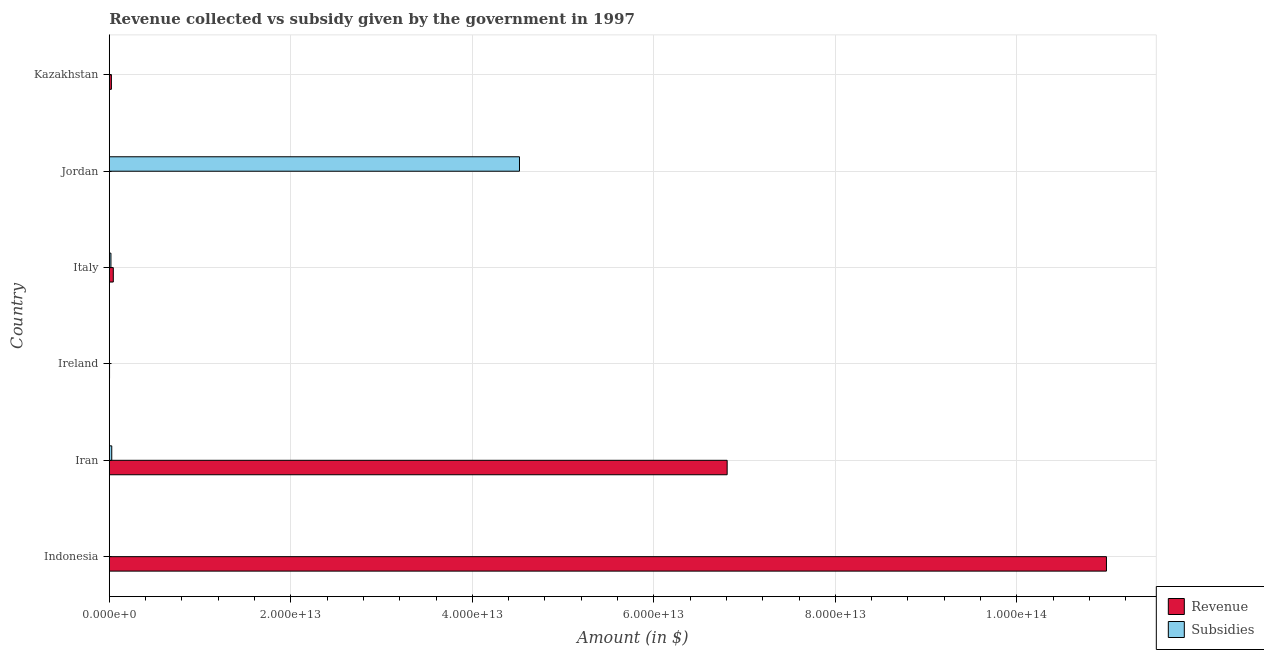Are the number of bars per tick equal to the number of legend labels?
Keep it short and to the point. Yes. Are the number of bars on each tick of the Y-axis equal?
Offer a terse response. Yes. How many bars are there on the 4th tick from the top?
Offer a very short reply. 2. How many bars are there on the 1st tick from the bottom?
Make the answer very short. 2. What is the label of the 3rd group of bars from the top?
Keep it short and to the point. Italy. What is the amount of subsidies given in Italy?
Offer a terse response. 1.83e+11. Across all countries, what is the maximum amount of subsidies given?
Ensure brevity in your answer.  4.52e+13. Across all countries, what is the minimum amount of subsidies given?
Offer a terse response. 1.45e+08. In which country was the amount of revenue collected maximum?
Give a very brief answer. Indonesia. In which country was the amount of revenue collected minimum?
Give a very brief answer. Jordan. What is the total amount of revenue collected in the graph?
Give a very brief answer. 1.79e+14. What is the difference between the amount of revenue collected in Ireland and that in Kazakhstan?
Your response must be concise. -2.04e+11. What is the difference between the amount of revenue collected in Iran and the amount of subsidies given in Jordan?
Your answer should be very brief. 2.29e+13. What is the average amount of subsidies given per country?
Provide a short and direct response. 7.61e+12. What is the difference between the amount of subsidies given and amount of revenue collected in Jordan?
Keep it short and to the point. 4.52e+13. In how many countries, is the amount of revenue collected greater than 64000000000000 $?
Ensure brevity in your answer.  2. What is the ratio of the amount of revenue collected in Indonesia to that in Ireland?
Your answer should be very brief. 3674.79. Is the difference between the amount of revenue collected in Iran and Kazakhstan greater than the difference between the amount of subsidies given in Iran and Kazakhstan?
Give a very brief answer. Yes. What is the difference between the highest and the second highest amount of subsidies given?
Your answer should be compact. 4.49e+13. What is the difference between the highest and the lowest amount of revenue collected?
Provide a succinct answer. 1.10e+14. In how many countries, is the amount of subsidies given greater than the average amount of subsidies given taken over all countries?
Ensure brevity in your answer.  1. What does the 2nd bar from the top in Italy represents?
Offer a very short reply. Revenue. What does the 2nd bar from the bottom in Iran represents?
Provide a short and direct response. Subsidies. How many bars are there?
Provide a succinct answer. 12. How many countries are there in the graph?
Your response must be concise. 6. What is the difference between two consecutive major ticks on the X-axis?
Make the answer very short. 2.00e+13. Are the values on the major ticks of X-axis written in scientific E-notation?
Ensure brevity in your answer.  Yes. Does the graph contain any zero values?
Provide a succinct answer. No. Does the graph contain grids?
Ensure brevity in your answer.  Yes. How are the legend labels stacked?
Offer a terse response. Vertical. What is the title of the graph?
Make the answer very short. Revenue collected vs subsidy given by the government in 1997. What is the label or title of the X-axis?
Provide a short and direct response. Amount (in $). What is the Amount (in $) of Revenue in Indonesia?
Your answer should be very brief. 1.10e+14. What is the Amount (in $) in Subsidies in Indonesia?
Offer a terse response. 9.20e+09. What is the Amount (in $) of Revenue in Iran?
Offer a very short reply. 6.81e+13. What is the Amount (in $) in Subsidies in Iran?
Make the answer very short. 2.72e+11. What is the Amount (in $) of Revenue in Ireland?
Provide a short and direct response. 2.99e+1. What is the Amount (in $) in Subsidies in Ireland?
Give a very brief answer. 1.45e+08. What is the Amount (in $) in Revenue in Italy?
Keep it short and to the point. 4.44e+11. What is the Amount (in $) in Subsidies in Italy?
Your answer should be very brief. 1.83e+11. What is the Amount (in $) in Revenue in Jordan?
Keep it short and to the point. 1.31e+09. What is the Amount (in $) of Subsidies in Jordan?
Make the answer very short. 4.52e+13. What is the Amount (in $) in Revenue in Kazakhstan?
Your response must be concise. 2.34e+11. What is the Amount (in $) of Subsidies in Kazakhstan?
Provide a succinct answer. 7.52e+08. Across all countries, what is the maximum Amount (in $) of Revenue?
Give a very brief answer. 1.10e+14. Across all countries, what is the maximum Amount (in $) of Subsidies?
Provide a succinct answer. 4.52e+13. Across all countries, what is the minimum Amount (in $) in Revenue?
Give a very brief answer. 1.31e+09. Across all countries, what is the minimum Amount (in $) in Subsidies?
Keep it short and to the point. 1.45e+08. What is the total Amount (in $) of Revenue in the graph?
Your response must be concise. 1.79e+14. What is the total Amount (in $) of Subsidies in the graph?
Provide a short and direct response. 4.57e+13. What is the difference between the Amount (in $) in Revenue in Indonesia and that in Iran?
Offer a very short reply. 4.18e+13. What is the difference between the Amount (in $) of Subsidies in Indonesia and that in Iran?
Provide a succinct answer. -2.63e+11. What is the difference between the Amount (in $) in Revenue in Indonesia and that in Ireland?
Provide a short and direct response. 1.10e+14. What is the difference between the Amount (in $) of Subsidies in Indonesia and that in Ireland?
Offer a very short reply. 9.05e+09. What is the difference between the Amount (in $) in Revenue in Indonesia and that in Italy?
Ensure brevity in your answer.  1.09e+14. What is the difference between the Amount (in $) in Subsidies in Indonesia and that in Italy?
Ensure brevity in your answer.  -1.74e+11. What is the difference between the Amount (in $) of Revenue in Indonesia and that in Jordan?
Offer a terse response. 1.10e+14. What is the difference between the Amount (in $) in Subsidies in Indonesia and that in Jordan?
Your response must be concise. -4.52e+13. What is the difference between the Amount (in $) in Revenue in Indonesia and that in Kazakhstan?
Your answer should be very brief. 1.10e+14. What is the difference between the Amount (in $) of Subsidies in Indonesia and that in Kazakhstan?
Provide a short and direct response. 8.44e+09. What is the difference between the Amount (in $) in Revenue in Iran and that in Ireland?
Ensure brevity in your answer.  6.81e+13. What is the difference between the Amount (in $) of Subsidies in Iran and that in Ireland?
Offer a terse response. 2.72e+11. What is the difference between the Amount (in $) of Revenue in Iran and that in Italy?
Make the answer very short. 6.76e+13. What is the difference between the Amount (in $) of Subsidies in Iran and that in Italy?
Provide a succinct answer. 8.93e+1. What is the difference between the Amount (in $) of Revenue in Iran and that in Jordan?
Give a very brief answer. 6.81e+13. What is the difference between the Amount (in $) in Subsidies in Iran and that in Jordan?
Provide a short and direct response. -4.49e+13. What is the difference between the Amount (in $) of Revenue in Iran and that in Kazakhstan?
Give a very brief answer. 6.78e+13. What is the difference between the Amount (in $) of Subsidies in Iran and that in Kazakhstan?
Provide a short and direct response. 2.71e+11. What is the difference between the Amount (in $) in Revenue in Ireland and that in Italy?
Make the answer very short. -4.14e+11. What is the difference between the Amount (in $) in Subsidies in Ireland and that in Italy?
Keep it short and to the point. -1.83e+11. What is the difference between the Amount (in $) in Revenue in Ireland and that in Jordan?
Ensure brevity in your answer.  2.86e+1. What is the difference between the Amount (in $) of Subsidies in Ireland and that in Jordan?
Offer a terse response. -4.52e+13. What is the difference between the Amount (in $) of Revenue in Ireland and that in Kazakhstan?
Your answer should be compact. -2.04e+11. What is the difference between the Amount (in $) in Subsidies in Ireland and that in Kazakhstan?
Provide a short and direct response. -6.07e+08. What is the difference between the Amount (in $) of Revenue in Italy and that in Jordan?
Your answer should be compact. 4.42e+11. What is the difference between the Amount (in $) in Subsidies in Italy and that in Jordan?
Offer a very short reply. -4.50e+13. What is the difference between the Amount (in $) in Revenue in Italy and that in Kazakhstan?
Provide a short and direct response. 2.10e+11. What is the difference between the Amount (in $) of Subsidies in Italy and that in Kazakhstan?
Offer a terse response. 1.82e+11. What is the difference between the Amount (in $) of Revenue in Jordan and that in Kazakhstan?
Ensure brevity in your answer.  -2.32e+11. What is the difference between the Amount (in $) in Subsidies in Jordan and that in Kazakhstan?
Offer a very short reply. 4.52e+13. What is the difference between the Amount (in $) in Revenue in Indonesia and the Amount (in $) in Subsidies in Iran?
Ensure brevity in your answer.  1.10e+14. What is the difference between the Amount (in $) in Revenue in Indonesia and the Amount (in $) in Subsidies in Ireland?
Keep it short and to the point. 1.10e+14. What is the difference between the Amount (in $) of Revenue in Indonesia and the Amount (in $) of Subsidies in Italy?
Provide a short and direct response. 1.10e+14. What is the difference between the Amount (in $) of Revenue in Indonesia and the Amount (in $) of Subsidies in Jordan?
Offer a very short reply. 6.47e+13. What is the difference between the Amount (in $) in Revenue in Indonesia and the Amount (in $) in Subsidies in Kazakhstan?
Provide a short and direct response. 1.10e+14. What is the difference between the Amount (in $) of Revenue in Iran and the Amount (in $) of Subsidies in Ireland?
Keep it short and to the point. 6.81e+13. What is the difference between the Amount (in $) in Revenue in Iran and the Amount (in $) in Subsidies in Italy?
Your answer should be compact. 6.79e+13. What is the difference between the Amount (in $) in Revenue in Iran and the Amount (in $) in Subsidies in Jordan?
Keep it short and to the point. 2.29e+13. What is the difference between the Amount (in $) of Revenue in Iran and the Amount (in $) of Subsidies in Kazakhstan?
Offer a very short reply. 6.81e+13. What is the difference between the Amount (in $) of Revenue in Ireland and the Amount (in $) of Subsidies in Italy?
Provide a succinct answer. -1.53e+11. What is the difference between the Amount (in $) in Revenue in Ireland and the Amount (in $) in Subsidies in Jordan?
Offer a very short reply. -4.52e+13. What is the difference between the Amount (in $) in Revenue in Ireland and the Amount (in $) in Subsidies in Kazakhstan?
Ensure brevity in your answer.  2.91e+1. What is the difference between the Amount (in $) in Revenue in Italy and the Amount (in $) in Subsidies in Jordan?
Give a very brief answer. -4.48e+13. What is the difference between the Amount (in $) of Revenue in Italy and the Amount (in $) of Subsidies in Kazakhstan?
Give a very brief answer. 4.43e+11. What is the difference between the Amount (in $) of Revenue in Jordan and the Amount (in $) of Subsidies in Kazakhstan?
Provide a short and direct response. 5.60e+08. What is the average Amount (in $) of Revenue per country?
Provide a succinct answer. 2.98e+13. What is the average Amount (in $) in Subsidies per country?
Ensure brevity in your answer.  7.61e+12. What is the difference between the Amount (in $) in Revenue and Amount (in $) in Subsidies in Indonesia?
Give a very brief answer. 1.10e+14. What is the difference between the Amount (in $) in Revenue and Amount (in $) in Subsidies in Iran?
Keep it short and to the point. 6.78e+13. What is the difference between the Amount (in $) of Revenue and Amount (in $) of Subsidies in Ireland?
Your answer should be compact. 2.98e+1. What is the difference between the Amount (in $) of Revenue and Amount (in $) of Subsidies in Italy?
Offer a very short reply. 2.61e+11. What is the difference between the Amount (in $) in Revenue and Amount (in $) in Subsidies in Jordan?
Provide a succinct answer. -4.52e+13. What is the difference between the Amount (in $) of Revenue and Amount (in $) of Subsidies in Kazakhstan?
Give a very brief answer. 2.33e+11. What is the ratio of the Amount (in $) of Revenue in Indonesia to that in Iran?
Keep it short and to the point. 1.61. What is the ratio of the Amount (in $) of Subsidies in Indonesia to that in Iran?
Offer a very short reply. 0.03. What is the ratio of the Amount (in $) of Revenue in Indonesia to that in Ireland?
Keep it short and to the point. 3674.79. What is the ratio of the Amount (in $) of Subsidies in Indonesia to that in Ireland?
Make the answer very short. 63.36. What is the ratio of the Amount (in $) in Revenue in Indonesia to that in Italy?
Offer a terse response. 247.7. What is the ratio of the Amount (in $) in Subsidies in Indonesia to that in Italy?
Give a very brief answer. 0.05. What is the ratio of the Amount (in $) of Revenue in Indonesia to that in Jordan?
Give a very brief answer. 8.38e+04. What is the ratio of the Amount (in $) in Subsidies in Indonesia to that in Jordan?
Provide a short and direct response. 0. What is the ratio of the Amount (in $) in Revenue in Indonesia to that in Kazakhstan?
Make the answer very short. 470.18. What is the ratio of the Amount (in $) of Subsidies in Indonesia to that in Kazakhstan?
Make the answer very short. 12.23. What is the ratio of the Amount (in $) of Revenue in Iran to that in Ireland?
Offer a very short reply. 2277.01. What is the ratio of the Amount (in $) of Subsidies in Iran to that in Ireland?
Make the answer very short. 1875.88. What is the ratio of the Amount (in $) of Revenue in Iran to that in Italy?
Ensure brevity in your answer.  153.49. What is the ratio of the Amount (in $) of Subsidies in Iran to that in Italy?
Provide a succinct answer. 1.49. What is the ratio of the Amount (in $) of Revenue in Iran to that in Jordan?
Your answer should be compact. 5.19e+04. What is the ratio of the Amount (in $) of Subsidies in Iran to that in Jordan?
Your answer should be very brief. 0.01. What is the ratio of the Amount (in $) of Revenue in Iran to that in Kazakhstan?
Make the answer very short. 291.34. What is the ratio of the Amount (in $) of Subsidies in Iran to that in Kazakhstan?
Provide a succinct answer. 362. What is the ratio of the Amount (in $) in Revenue in Ireland to that in Italy?
Your answer should be very brief. 0.07. What is the ratio of the Amount (in $) of Subsidies in Ireland to that in Italy?
Provide a succinct answer. 0. What is the ratio of the Amount (in $) in Revenue in Ireland to that in Jordan?
Provide a short and direct response. 22.79. What is the ratio of the Amount (in $) in Subsidies in Ireland to that in Jordan?
Your answer should be very brief. 0. What is the ratio of the Amount (in $) of Revenue in Ireland to that in Kazakhstan?
Offer a very short reply. 0.13. What is the ratio of the Amount (in $) of Subsidies in Ireland to that in Kazakhstan?
Ensure brevity in your answer.  0.19. What is the ratio of the Amount (in $) in Revenue in Italy to that in Jordan?
Keep it short and to the point. 338.14. What is the ratio of the Amount (in $) in Subsidies in Italy to that in Jordan?
Your answer should be compact. 0. What is the ratio of the Amount (in $) in Revenue in Italy to that in Kazakhstan?
Make the answer very short. 1.9. What is the ratio of the Amount (in $) in Subsidies in Italy to that in Kazakhstan?
Give a very brief answer. 243.28. What is the ratio of the Amount (in $) of Revenue in Jordan to that in Kazakhstan?
Ensure brevity in your answer.  0.01. What is the ratio of the Amount (in $) in Subsidies in Jordan to that in Kazakhstan?
Your response must be concise. 6.01e+04. What is the difference between the highest and the second highest Amount (in $) in Revenue?
Keep it short and to the point. 4.18e+13. What is the difference between the highest and the second highest Amount (in $) of Subsidies?
Make the answer very short. 4.49e+13. What is the difference between the highest and the lowest Amount (in $) in Revenue?
Give a very brief answer. 1.10e+14. What is the difference between the highest and the lowest Amount (in $) of Subsidies?
Your answer should be compact. 4.52e+13. 